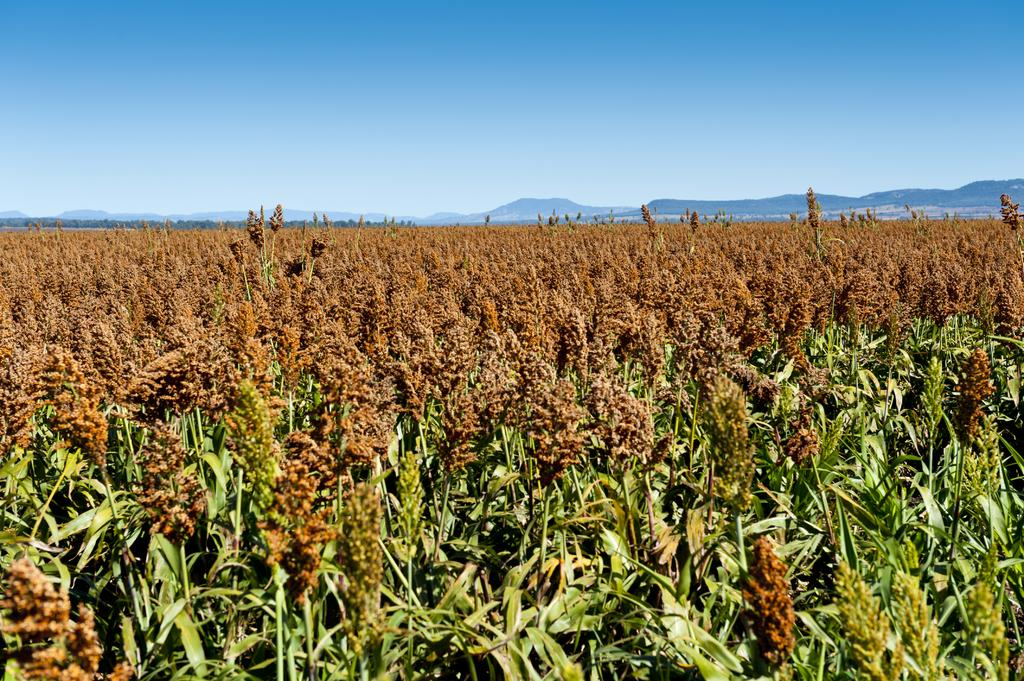What type of vegetation can be seen in the image? There are crops in the image. What natural features are visible in the background of the image? There are mountains in the background of the image. What else can be seen in the background of the image? The sky is visible in the background of the image. How many animals can be seen wearing suits in the image? There are no animals wearing suits in the image. What color are the eyes of the person in the image? There is no person present in the image, so it is not possible to determine the color of their eyes. 